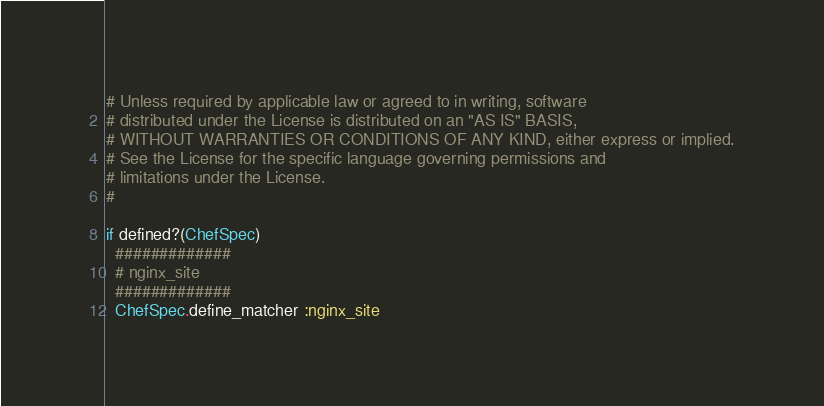Convert code to text. <code><loc_0><loc_0><loc_500><loc_500><_Ruby_># Unless required by applicable law or agreed to in writing, software
# distributed under the License is distributed on an "AS IS" BASIS,
# WITHOUT WARRANTIES OR CONDITIONS OF ANY KIND, either express or implied.
# See the License for the specific language governing permissions and
# limitations under the License.
#

if defined?(ChefSpec)
  #############
  # nginx_site
  #############
  ChefSpec.define_matcher :nginx_site
</code> 